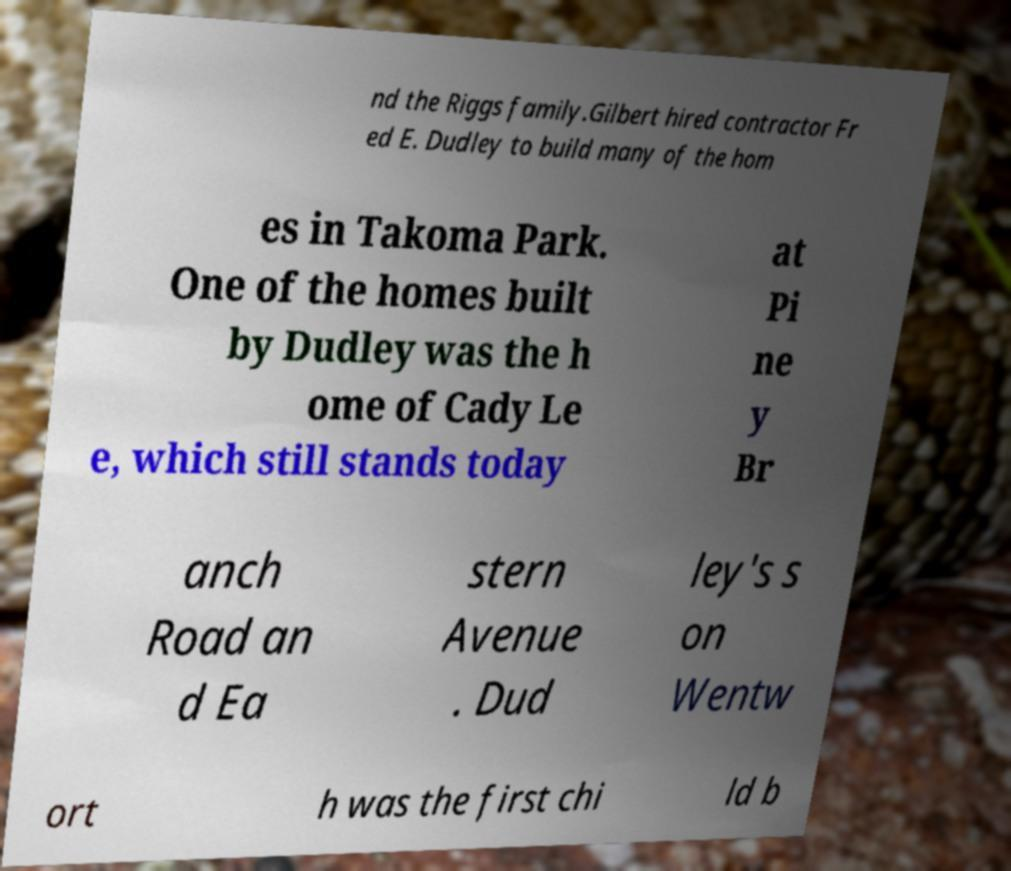Could you extract and type out the text from this image? nd the Riggs family.Gilbert hired contractor Fr ed E. Dudley to build many of the hom es in Takoma Park. One of the homes built by Dudley was the h ome of Cady Le e, which still stands today at Pi ne y Br anch Road an d Ea stern Avenue . Dud ley's s on Wentw ort h was the first chi ld b 